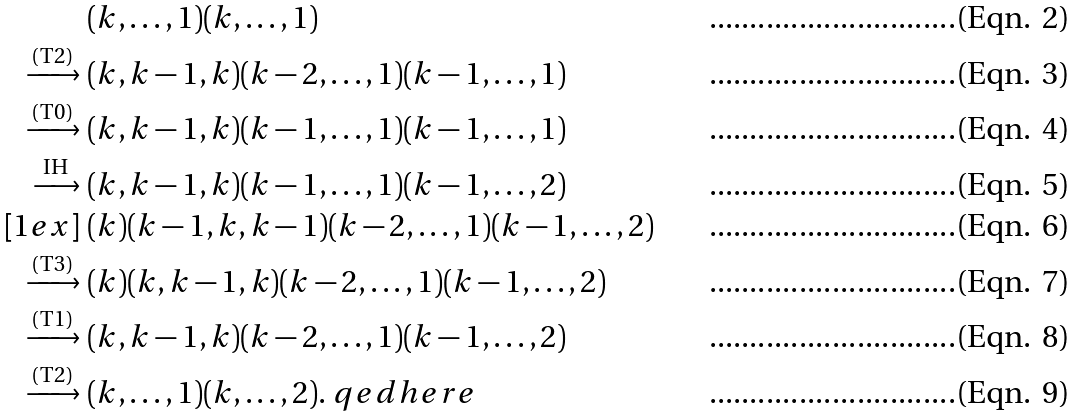Convert formula to latex. <formula><loc_0><loc_0><loc_500><loc_500>& ( k , \dots , 1 ) ( k , \dots , 1 ) \\ \xrightarrow { \text {(T2)} } \ & ( k , k - 1 , k ) ( k - 2 , \dots , 1 ) ( k - 1 , \dots , 1 ) \\ \xrightarrow { \text {(T0)} } \ & ( k , k - 1 , k ) ( k - 1 , \dots , 1 ) ( k - 1 , \dots , 1 ) \\ \xrightarrow { \text {\ IH\ } } \ & ( k , k - 1 , k ) ( k - 1 , \dots , 1 ) ( k - 1 , \dots , 2 ) \\ [ 1 e x ] \ & ( k ) ( k - 1 , k , k - 1 ) ( k - 2 , \dots , 1 ) ( k - 1 , \dots , 2 ) \\ \xrightarrow { \text {(T3)} } \ & ( k ) ( k , k - 1 , k ) ( k - 2 , \dots , 1 ) ( k - 1 , \dots , 2 ) \\ \xrightarrow { \text {(T1)} } \ & ( k , k - 1 , k ) ( k - 2 , \dots , 1 ) ( k - 1 , \dots , 2 ) \\ \xrightarrow { \text {(T2)} } \ & ( k , \dots , 1 ) ( k , \dots , 2 ) . \ q e d h e r e</formula> 